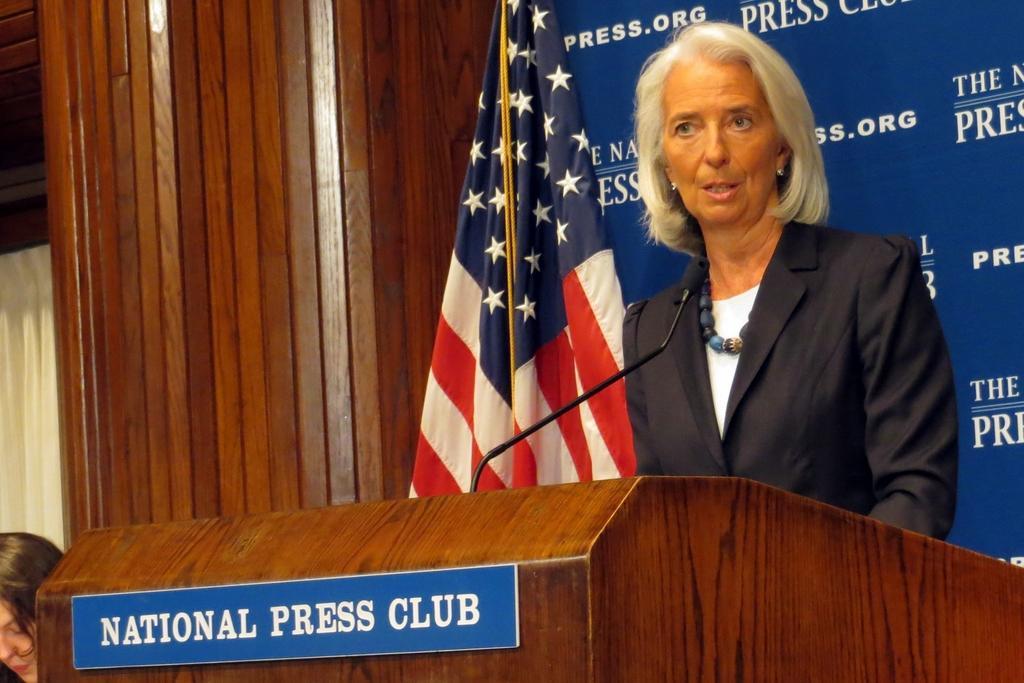Can you describe this image briefly? In the image there is a board attached to the table, behind the table there is a woman and she is taking something, behind her there is a banner and in front of the banner there is a flag and on the left side of the table there is a woman, behind her there is a wooden wall. 